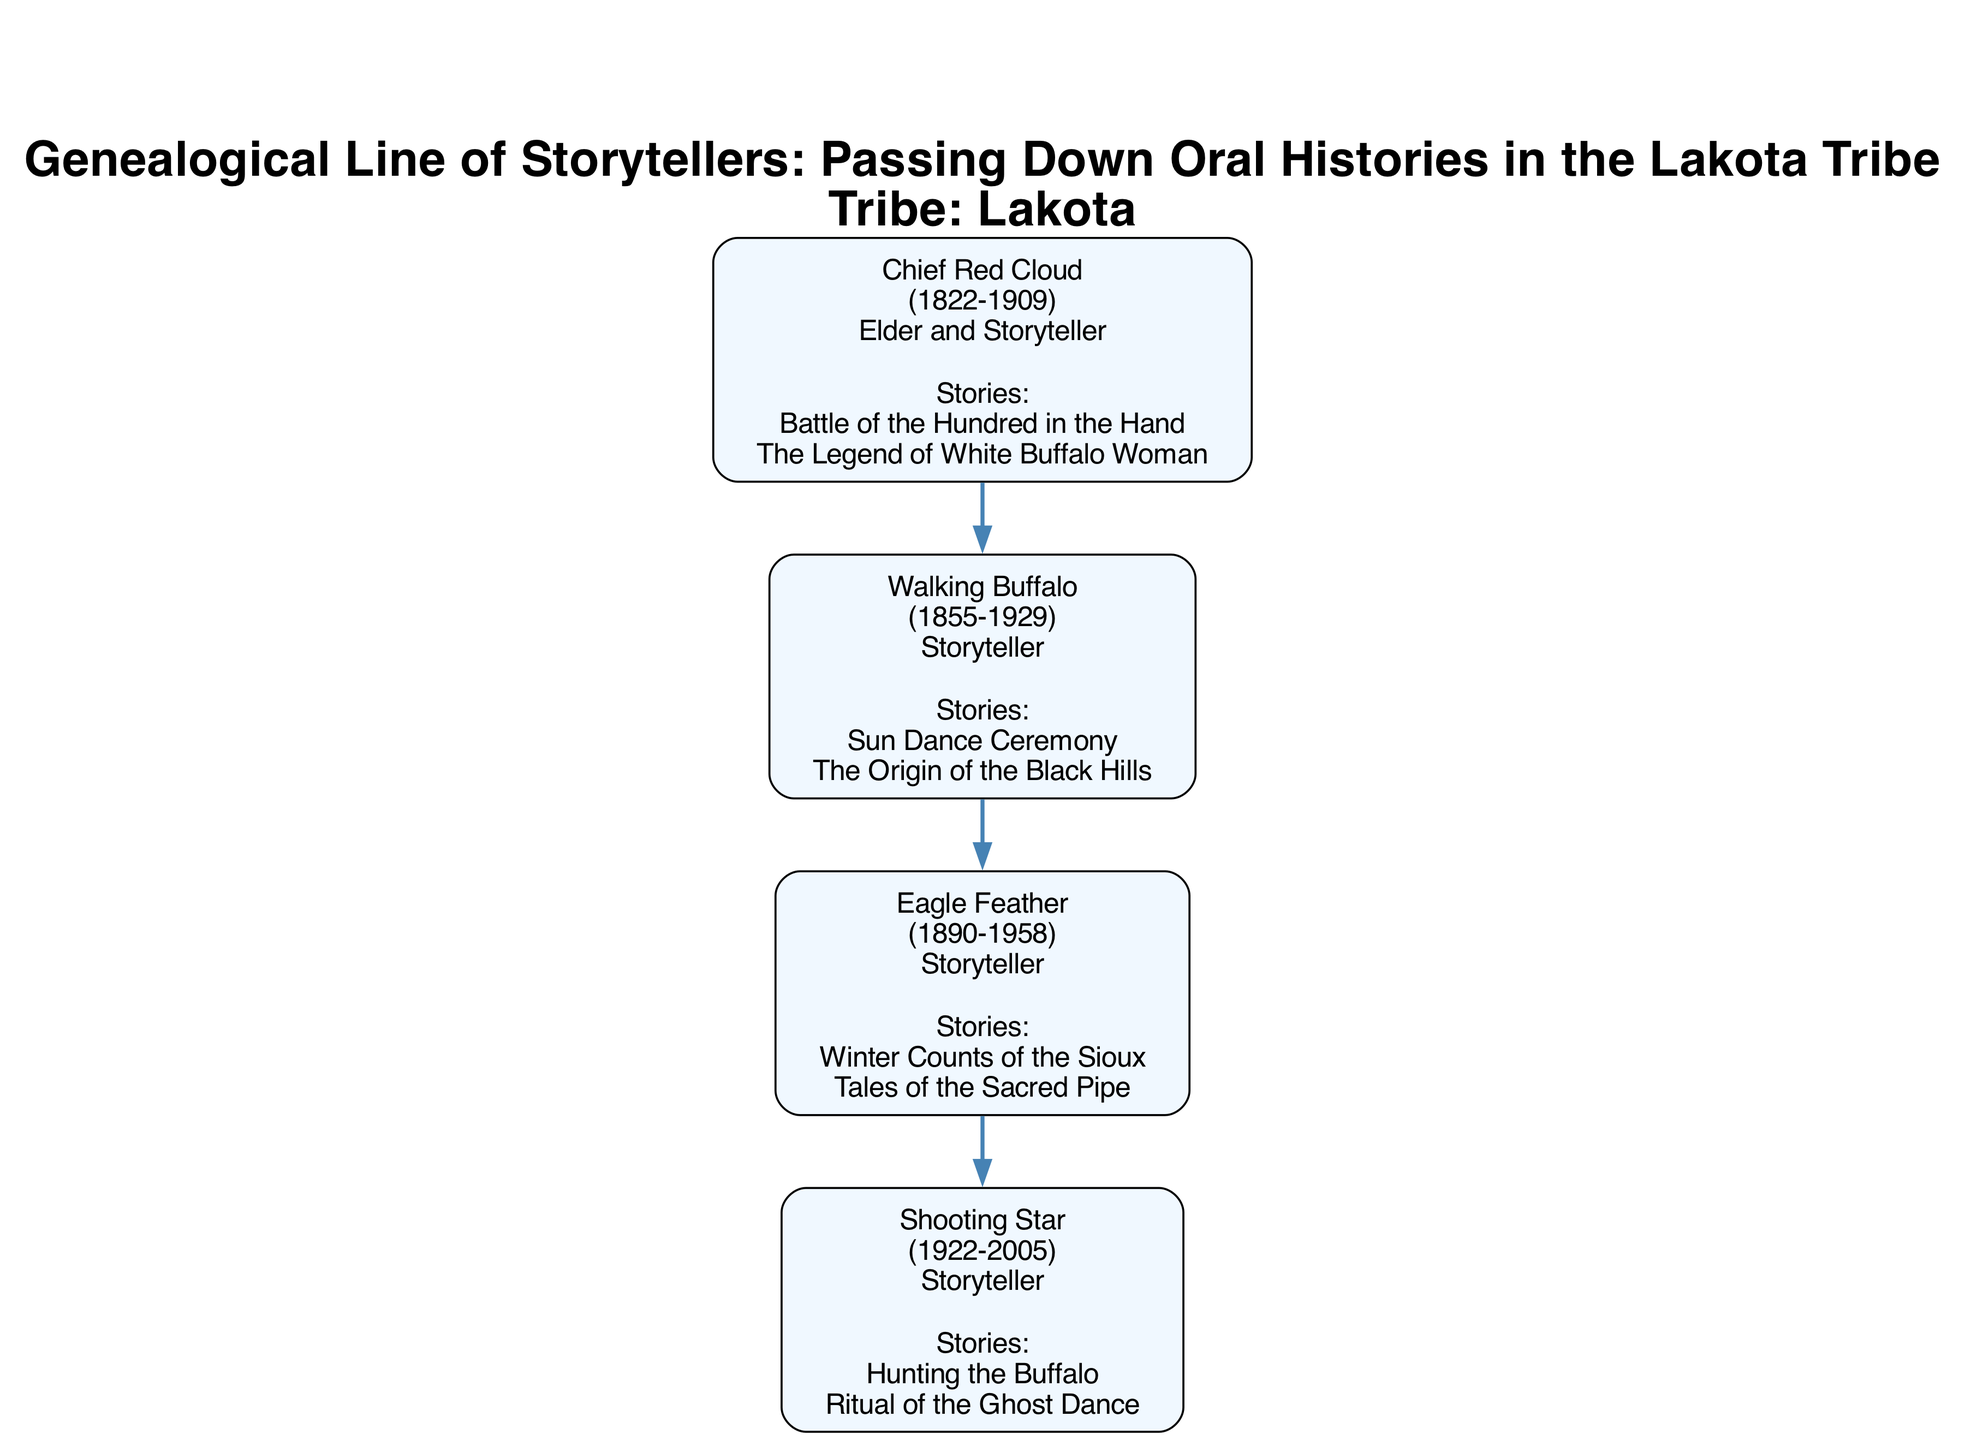What is the birth year of Chief Red Cloud? The diagram lists Chief Red Cloud's birth year in his node. By examining the node labeled "Chief Red Cloud," I can see that his birth year is stated as 1822.
Answer: 1822 How many children did Walking Buffalo have? Walking Buffalo is represented as a parent node with an associated child node. By counting the children listed in his node under "children," I find that he has one child, which is Eagle Feather.
Answer: 1 Which story was conveyed by Eagle Feather? The diagram includes a list of stories conveyed by each storyteller in their respective nodes. By checking the node for Eagle Feather, I see he conveyed "Winter Counts of the Sioux."
Answer: Winter Counts of the Sioux What is the death year of Shooting Star? The node for Shooting Star contains specific dates related to his life. By looking closely at the information provided in his node, I find that the death year is indicated as 2005.
Answer: 2005 Who is the great-grandchild of Chief Red Cloud? To find the great-grandchild, I follow the genealogical line from Chief Red Cloud down to his descendants. Starting at Chief Red Cloud, he has a child, Walking Buffalo, who has a child, Eagle Feather, who then has a child, Shooting Star. Therefore, the great-grandchild of Chief Red Cloud is Shooting Star.
Answer: Shooting Star What stories were passed down by the lineage from Chief Red Cloud to Shooting Star? I need to trace the connections from Chief Red Cloud through each storyteller node to see the stories conveyed at each level. Chief Red Cloud conveys "Battle of the Hundred in the Hand" and "The Legend of White Buffalo." Then, Walking Buffalo conveys "Sun Dance Ceremony" and "The Origin of the Black Hills." Next, Eagle Feather conveys "Winter Counts of the Sioux" and "Tales of the Sacred Pipe." Finally, Shooting Star conveys "Hunting the Buffalo" and "Ritual of the Ghost Dance." Thus, the stories passed down through this lineage include all these titles.
Answer: Battle of the Hundred in the Hand, The Legend of White Buffalo, Sun Dance Ceremony, The Origin of the Black Hills, Winter Counts of the Sioux, Tales of the Sacred Pipe, Hunting the Buffalo, Ritual of the Ghost Dance What role did Walking Buffalo have? To find the role of Walking Buffalo, I look at his node where his information is provided. The category labeled "role" directly shows that he is listed as a "Storyteller."
Answer: Storyteller 